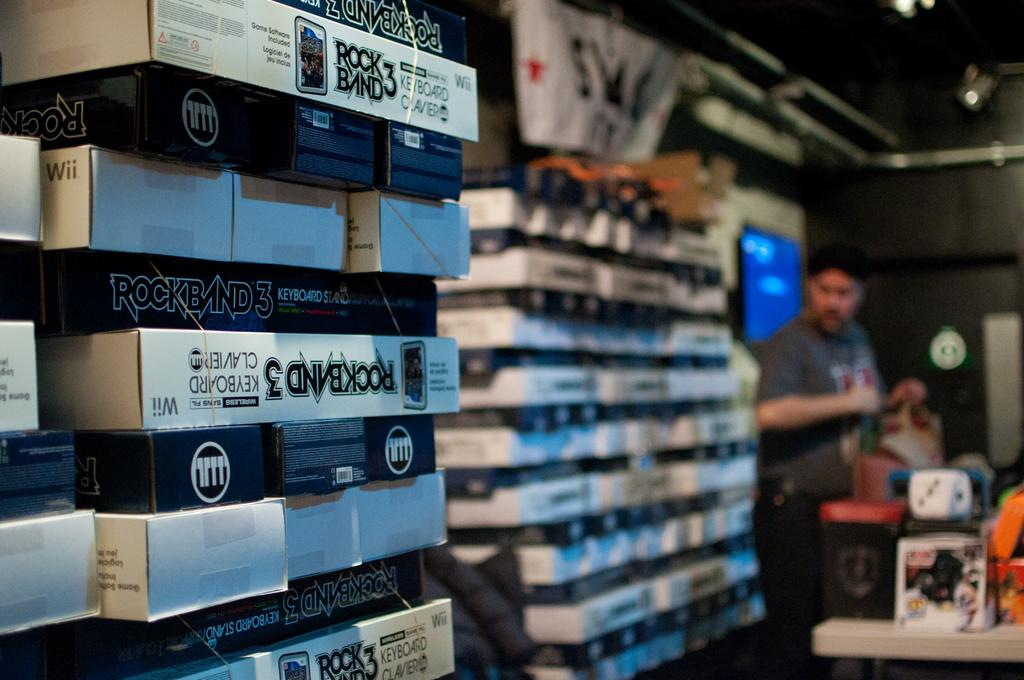<image>
Present a compact description of the photo's key features. game boxes with one of them that says 'rockband 3' 